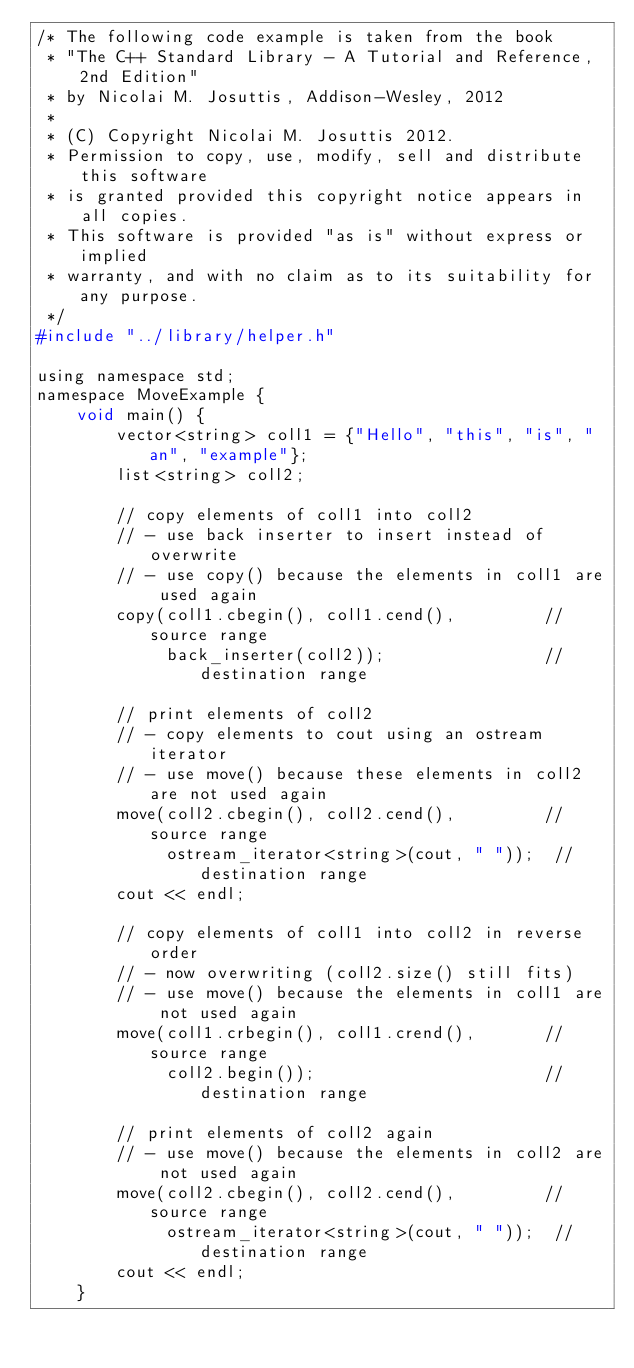Convert code to text. <code><loc_0><loc_0><loc_500><loc_500><_C_>/* The following code example is taken from the book
 * "The C++ Standard Library - A Tutorial and Reference, 2nd Edition"
 * by Nicolai M. Josuttis, Addison-Wesley, 2012
 *
 * (C) Copyright Nicolai M. Josuttis 2012.
 * Permission to copy, use, modify, sell and distribute this software
 * is granted provided this copyright notice appears in all copies.
 * This software is provided "as is" without express or implied
 * warranty, and with no claim as to its suitability for any purpose.
 */
#include "../library/helper.h"

using namespace std;
namespace MoveExample {
    void main() {
        vector<string> coll1 = {"Hello", "this", "is", "an", "example"};
        list<string> coll2;

        // copy elements of coll1 into coll2
        // - use back inserter to insert instead of overwrite
        // - use copy() because the elements in coll1 are used again
        copy(coll1.cbegin(), coll1.cend(),         // source range
             back_inserter(coll2));                // destination range

        // print elements of coll2
        // - copy elements to cout using an ostream iterator
        // - use move() because these elements in coll2 are not used again
        move(coll2.cbegin(), coll2.cend(),         // source range
             ostream_iterator<string>(cout, " "));  // destination range
        cout << endl;

        // copy elements of coll1 into coll2 in reverse order
        // - now overwriting (coll2.size() still fits)
        // - use move() because the elements in coll1 are not used again
        move(coll1.crbegin(), coll1.crend(),       // source range
             coll2.begin());                       // destination range

        // print elements of coll2 again
        // - use move() because the elements in coll2 are not used again
        move(coll2.cbegin(), coll2.cend(),         // source range
             ostream_iterator<string>(cout, " "));  // destination range
        cout << endl;
    }
</code> 